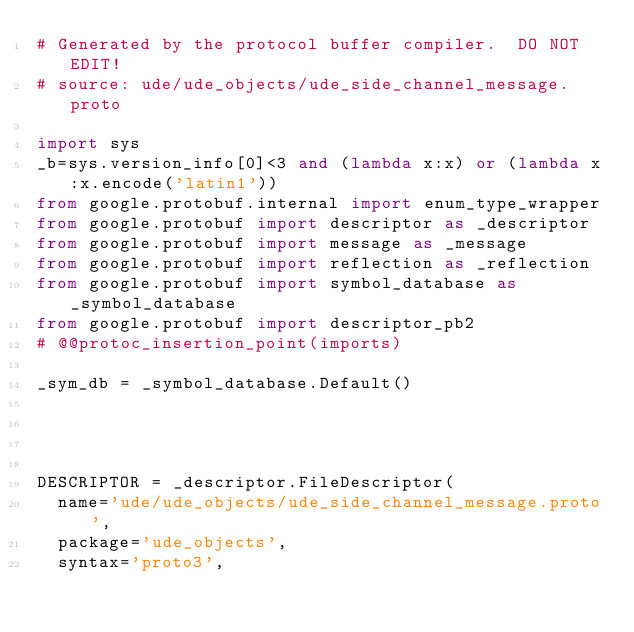<code> <loc_0><loc_0><loc_500><loc_500><_Python_># Generated by the protocol buffer compiler.  DO NOT EDIT!
# source: ude/ude_objects/ude_side_channel_message.proto

import sys
_b=sys.version_info[0]<3 and (lambda x:x) or (lambda x:x.encode('latin1'))
from google.protobuf.internal import enum_type_wrapper
from google.protobuf import descriptor as _descriptor
from google.protobuf import message as _message
from google.protobuf import reflection as _reflection
from google.protobuf import symbol_database as _symbol_database
from google.protobuf import descriptor_pb2
# @@protoc_insertion_point(imports)

_sym_db = _symbol_database.Default()




DESCRIPTOR = _descriptor.FileDescriptor(
  name='ude/ude_objects/ude_side_channel_message.proto',
  package='ude_objects',
  syntax='proto3',</code> 